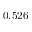Convert formula to latex. <formula><loc_0><loc_0><loc_500><loc_500>0 . 5 2 6</formula> 